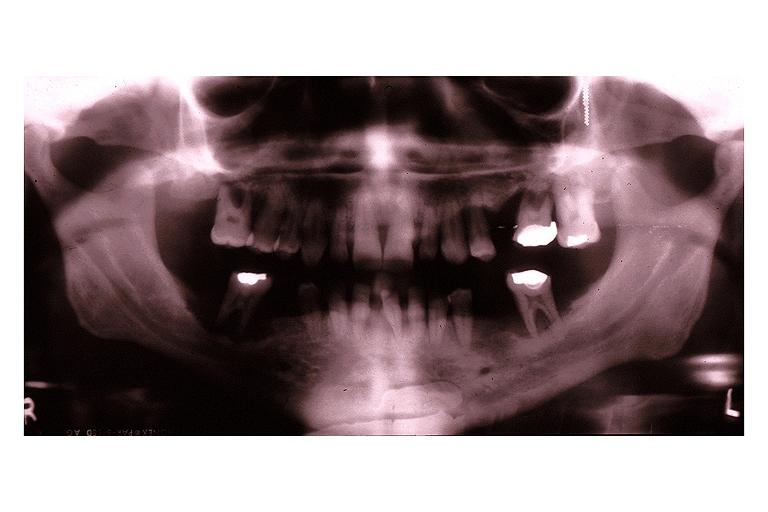does peritoneal fluid show langerhans cell histiocytosis eosinophilic granuloma?
Answer the question using a single word or phrase. No 